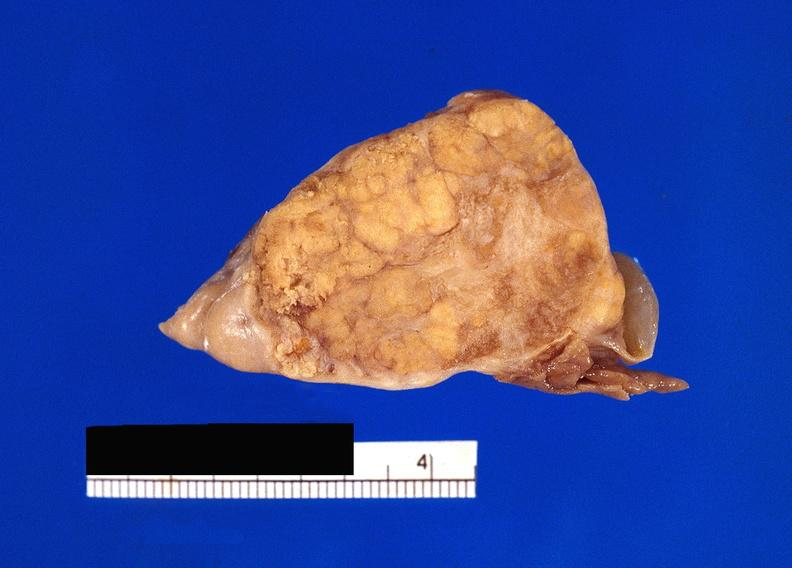does granuloma show pancreatic fat necrosis?
Answer the question using a single word or phrase. No 